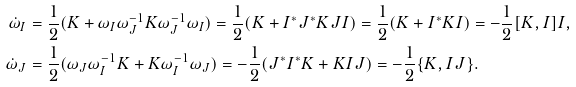Convert formula to latex. <formula><loc_0><loc_0><loc_500><loc_500>\dot { \omega } _ { I } & = \frac { 1 } { 2 } ( K + \omega _ { I } \omega _ { J } ^ { - 1 } K \omega _ { J } ^ { - 1 } \omega _ { I } ) = \frac { 1 } { 2 } ( K + I ^ { * } J ^ { * } K J I ) = \frac { 1 } { 2 } ( K + I ^ { * } K I ) = - \frac { 1 } { 2 } [ K , I ] I , \\ \dot { \omega } _ { J } & = \frac { 1 } { 2 } ( \omega _ { J } \omega _ { I } ^ { - 1 } K + K \omega _ { I } ^ { - 1 } \omega _ { J } ) = - \frac { 1 } { 2 } ( J ^ { * } I ^ { * } K + K I J ) = - \frac { 1 } { 2 } \{ K , I J \} .</formula> 